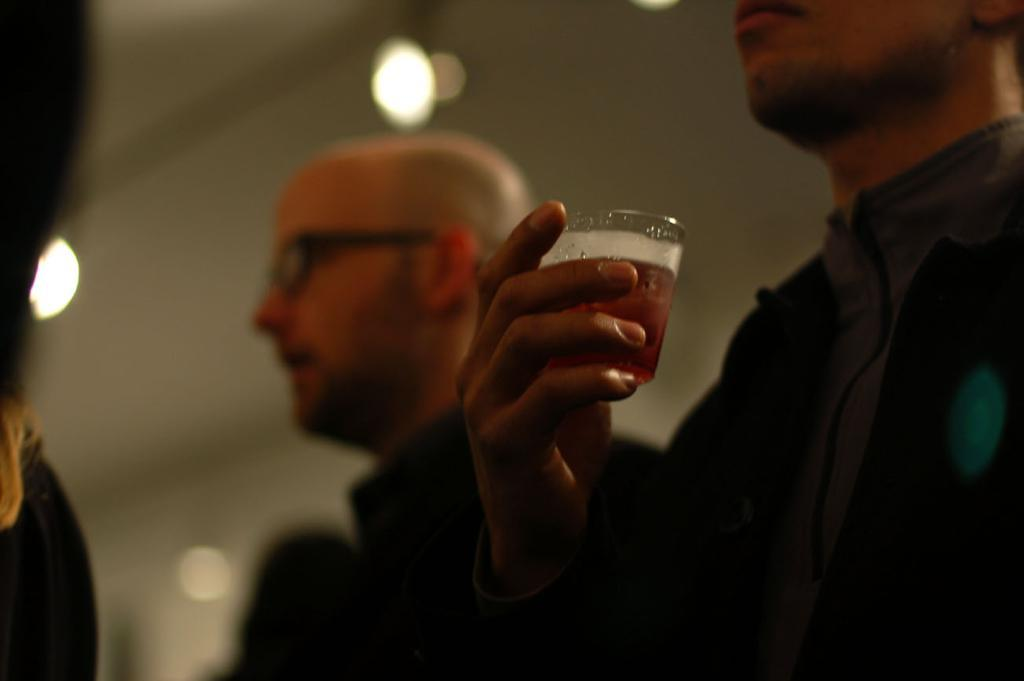What is the position of the man on the right side of the image? There is a man standing on the right side of the image. What is the man on the right side holding? The man on the right side is holding a glass. Can you describe the other man in the image? There is another man in the center of the image. What type of magic is the man on the right side performing in the image? There is no indication of magic or any magical activity in the image. 